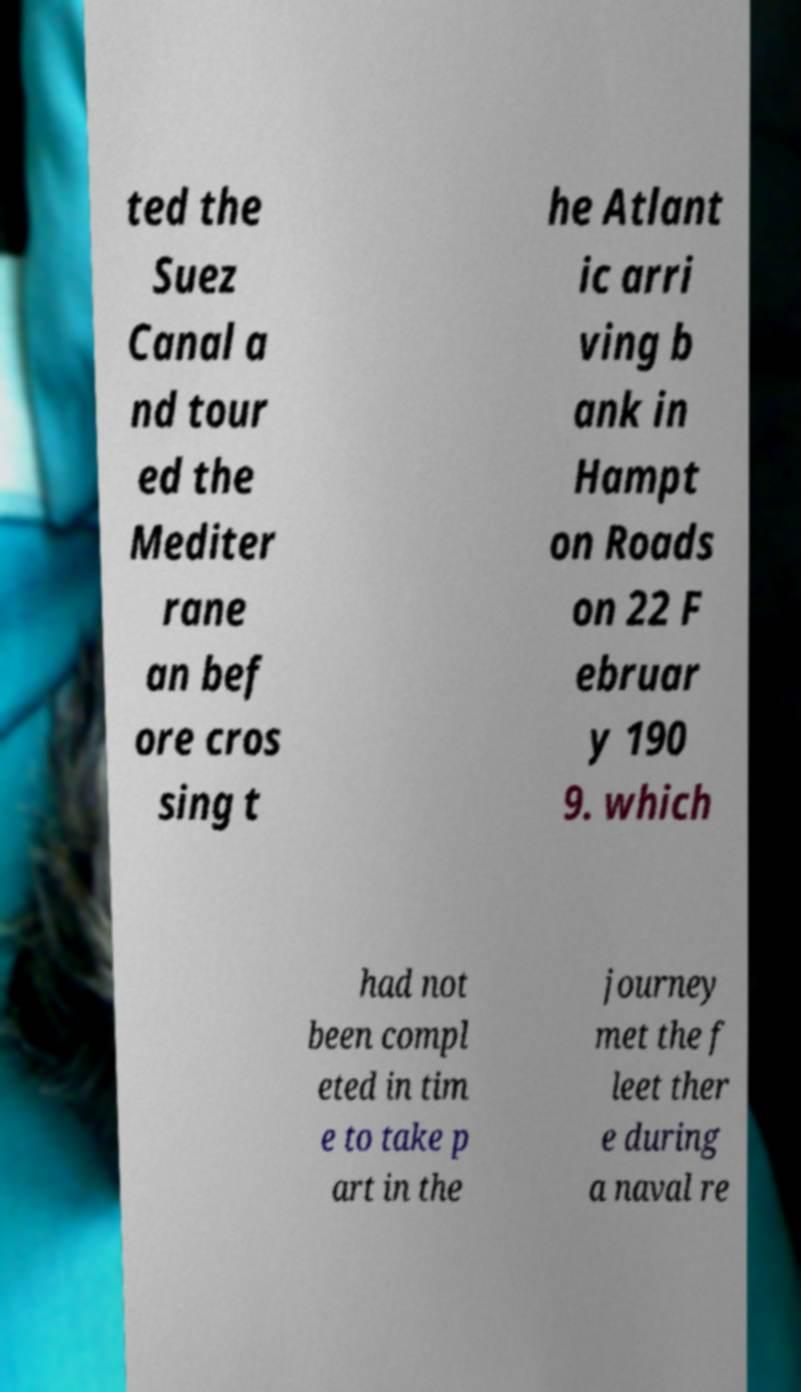Can you read and provide the text displayed in the image?This photo seems to have some interesting text. Can you extract and type it out for me? ted the Suez Canal a nd tour ed the Mediter rane an bef ore cros sing t he Atlant ic arri ving b ank in Hampt on Roads on 22 F ebruar y 190 9. which had not been compl eted in tim e to take p art in the journey met the f leet ther e during a naval re 